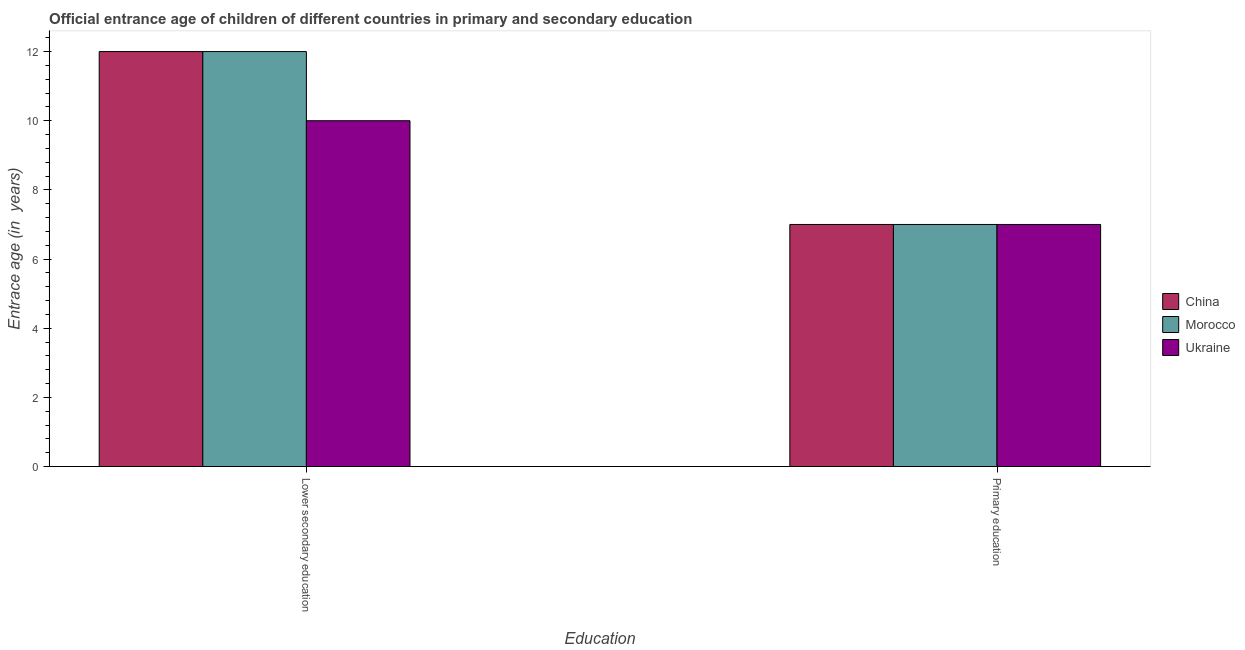How many groups of bars are there?
Provide a succinct answer. 2. How many bars are there on the 2nd tick from the left?
Your answer should be very brief. 3. How many bars are there on the 1st tick from the right?
Provide a succinct answer. 3. What is the entrance age of children in lower secondary education in China?
Give a very brief answer. 12. Across all countries, what is the maximum entrance age of children in lower secondary education?
Offer a terse response. 12. Across all countries, what is the minimum entrance age of children in lower secondary education?
Your answer should be very brief. 10. In which country was the entrance age of children in lower secondary education maximum?
Make the answer very short. China. In which country was the entrance age of children in lower secondary education minimum?
Your response must be concise. Ukraine. What is the total entrance age of children in lower secondary education in the graph?
Offer a very short reply. 34. What is the difference between the entrance age of chiildren in primary education in Morocco and that in China?
Give a very brief answer. 0. What is the difference between the entrance age of chiildren in primary education in China and the entrance age of children in lower secondary education in Ukraine?
Your response must be concise. -3. What is the average entrance age of chiildren in primary education per country?
Ensure brevity in your answer.  7. What is the difference between the entrance age of children in lower secondary education and entrance age of chiildren in primary education in Ukraine?
Make the answer very short. 3. Is the entrance age of chiildren in primary education in Ukraine less than that in Morocco?
Make the answer very short. No. What does the 3rd bar from the left in Primary education represents?
Keep it short and to the point. Ukraine. How many bars are there?
Provide a short and direct response. 6. Are all the bars in the graph horizontal?
Offer a terse response. No. How many countries are there in the graph?
Your response must be concise. 3. Are the values on the major ticks of Y-axis written in scientific E-notation?
Make the answer very short. No. Does the graph contain any zero values?
Your answer should be very brief. No. Does the graph contain grids?
Provide a short and direct response. No. Where does the legend appear in the graph?
Your answer should be compact. Center right. How many legend labels are there?
Offer a terse response. 3. How are the legend labels stacked?
Offer a very short reply. Vertical. What is the title of the graph?
Your answer should be compact. Official entrance age of children of different countries in primary and secondary education. Does "Netherlands" appear as one of the legend labels in the graph?
Your answer should be very brief. No. What is the label or title of the X-axis?
Give a very brief answer. Education. What is the label or title of the Y-axis?
Offer a very short reply. Entrace age (in  years). What is the Entrace age (in  years) in China in Lower secondary education?
Provide a short and direct response. 12. What is the Entrace age (in  years) in Morocco in Lower secondary education?
Give a very brief answer. 12. What is the Entrace age (in  years) in Ukraine in Primary education?
Keep it short and to the point. 7. Across all Education, what is the maximum Entrace age (in  years) in China?
Your answer should be very brief. 12. Across all Education, what is the maximum Entrace age (in  years) in Morocco?
Offer a terse response. 12. Across all Education, what is the minimum Entrace age (in  years) of Ukraine?
Ensure brevity in your answer.  7. What is the total Entrace age (in  years) in China in the graph?
Keep it short and to the point. 19. What is the difference between the Entrace age (in  years) in Morocco in Lower secondary education and that in Primary education?
Offer a very short reply. 5. What is the difference between the Entrace age (in  years) in Ukraine in Lower secondary education and that in Primary education?
Provide a short and direct response. 3. What is the difference between the Entrace age (in  years) in China in Lower secondary education and the Entrace age (in  years) in Ukraine in Primary education?
Your answer should be very brief. 5. What is the difference between the Entrace age (in  years) of Morocco in Lower secondary education and the Entrace age (in  years) of Ukraine in Primary education?
Keep it short and to the point. 5. What is the average Entrace age (in  years) in China per Education?
Provide a short and direct response. 9.5. What is the difference between the Entrace age (in  years) of China and Entrace age (in  years) of Morocco in Lower secondary education?
Your answer should be compact. 0. What is the difference between the Entrace age (in  years) of Morocco and Entrace age (in  years) of Ukraine in Lower secondary education?
Offer a terse response. 2. What is the ratio of the Entrace age (in  years) of China in Lower secondary education to that in Primary education?
Offer a terse response. 1.71. What is the ratio of the Entrace age (in  years) in Morocco in Lower secondary education to that in Primary education?
Keep it short and to the point. 1.71. What is the ratio of the Entrace age (in  years) of Ukraine in Lower secondary education to that in Primary education?
Provide a succinct answer. 1.43. What is the difference between the highest and the second highest Entrace age (in  years) in Morocco?
Your response must be concise. 5. What is the difference between the highest and the lowest Entrace age (in  years) of Morocco?
Provide a succinct answer. 5. What is the difference between the highest and the lowest Entrace age (in  years) of Ukraine?
Your response must be concise. 3. 